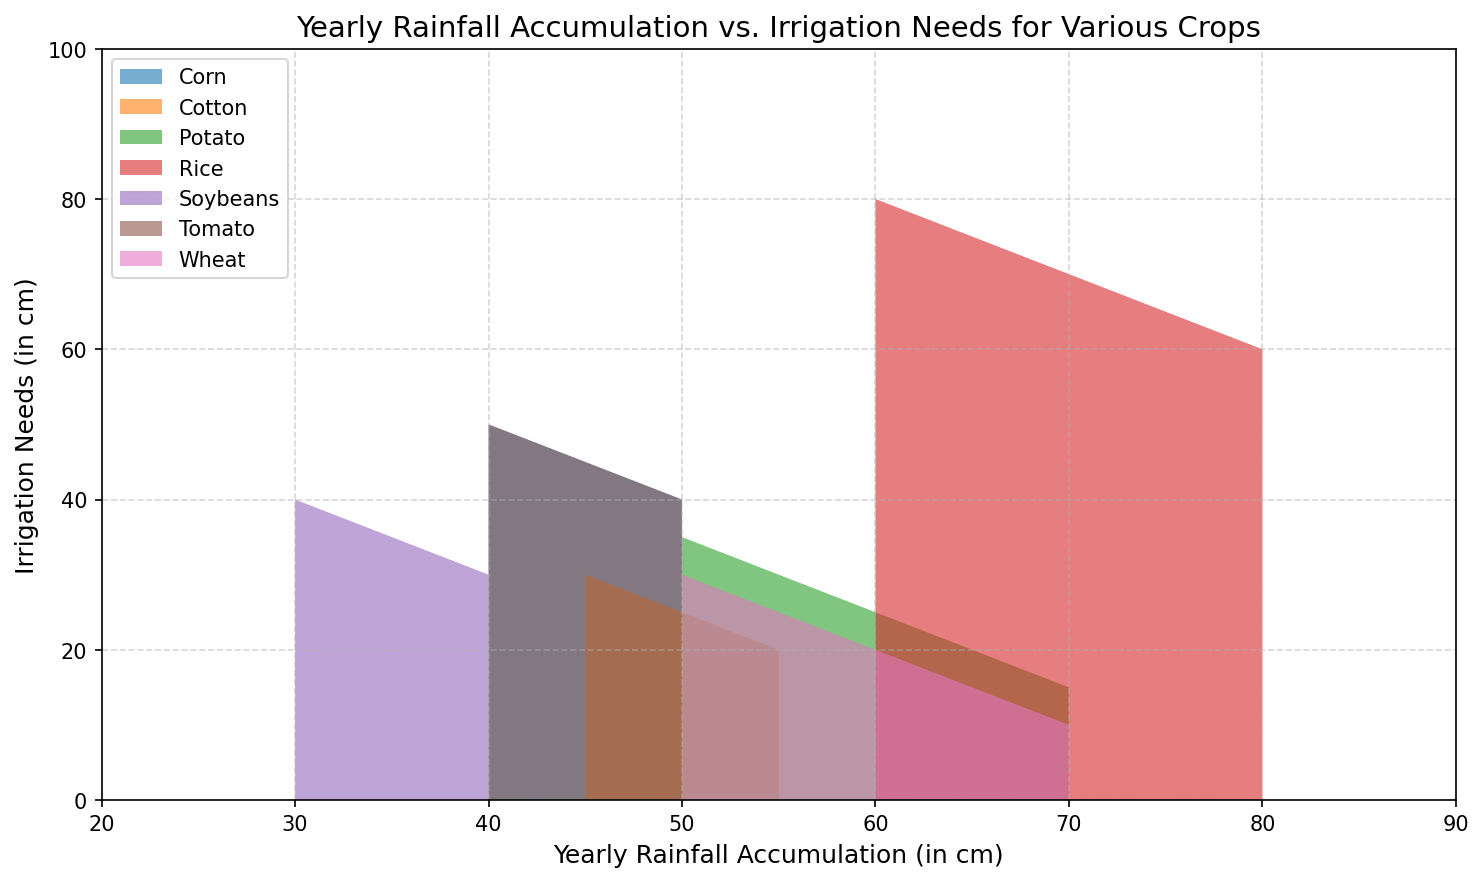What crop has the highest irrigation need with 50 cm of yearly rainfall accumulation? The figure shows the irrigation needs for various crops under different yearly rainfall accumulations. By examining the data for 50 cm rainfall, locate the crop with the largest irrigation need value.
Answer: Corn Which crop has the lowest irrigation need when the yearly rainfall accumulation is 60 cm? Look at the point where the yearly rainfall accumulation is 60 cm for each crop, then compare the irrigation needs at this point. The lowest value indicates the crop with the lowest irrigation need.
Answer: Wheat At 70 cm of yearly rainfall accumulation, what is the irrigation need for Rice and how does it compare to Soybeans? Locate the points for 70 cm rainfall on the figure for both Rice and Soybeans and read off the corresponding irrigation needs. Then directly compare these values.
Answer: 70 cm for Rice is 70 cm, and for Soybeans, it's absent How do the irrigation needs of Potato and Tomato compare at 50 cm of yearly rainfall accumulation? Find the irrigation need for both Potato and Tomato at 50 cm of rainfall from the figure and compare these two values.
Answer: Potato needs 35 cm, while Tomato needs 40 cm Which crop's irrigation need decreases the most as yearly rainfall accumulation increases from 50 to 70 cm? Calculate the difference in irrigation needs at 50 cm and 70 cm rainfall for each crop, then identify the crop with the largest difference.
Answer: Rice (from 80 cm to 60 cm, decrease of 20 cm) What is the average irrigation need for Soybeans at the three different yearly rainfall accumulations provided? Find the irrigation needs for Soybeans at each given rainfall accumulation, sum them, and then divide by the number of points to get the average. Needs are shown at 30 cm, 35 cm, and 40 cm rainfall. (40+35+30)/3 = 35
Answer: 35 cm Compare the irrigation needs of Cotton at 45 cm and 55 cm of yearly rainfall accumulation. How do they differ? Locate the irrigation needs for Cotton at both 45 cm and 55 cm in rainfall. Subtract the lower value from the higher value to find the difference.
Answer: At 45 cm, it’s 30 cm, and at 55 cm, it’s 20 cm, so the difference is 10 cm For which crop does the irrigation need stay the same from 40 cm to 45 cm of yearly rainfall accumulation? Identify which crop shows no change in irrigation need between the points of 40 cm and 45 cm of yearly rainfall by referring to the visual gaps on the chart.
Answer: Corn What is the total irrigation need for all crops at 50 cm of yearly rainfall accumulation? Sum the irrigation needs for all crops shown at the 50 cm rainfall mark. Wheat: 20, Corn: 45, Soybeans: 30, Rice: 80, Potato: 35, Tomato: 40, Cotton: 25. Total is 20 + 45 + 30 + 80 + 35 + 40 + 25 = 275
Answer: 275 cm Based on the chart, which crop would require the least additional irrigation if the yearly rainfall were to increase from 60 cm to 70 cm? Identify the drops in irrigation needs between 60 cm and 70 cm for each crop and find the smallest change as the least additional irrigation. Ensure you skip crops where there’s no data at 70 cm.
Answer: Wheat 